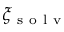Convert formula to latex. <formula><loc_0><loc_0><loc_500><loc_500>\xi _ { s o l v }</formula> 